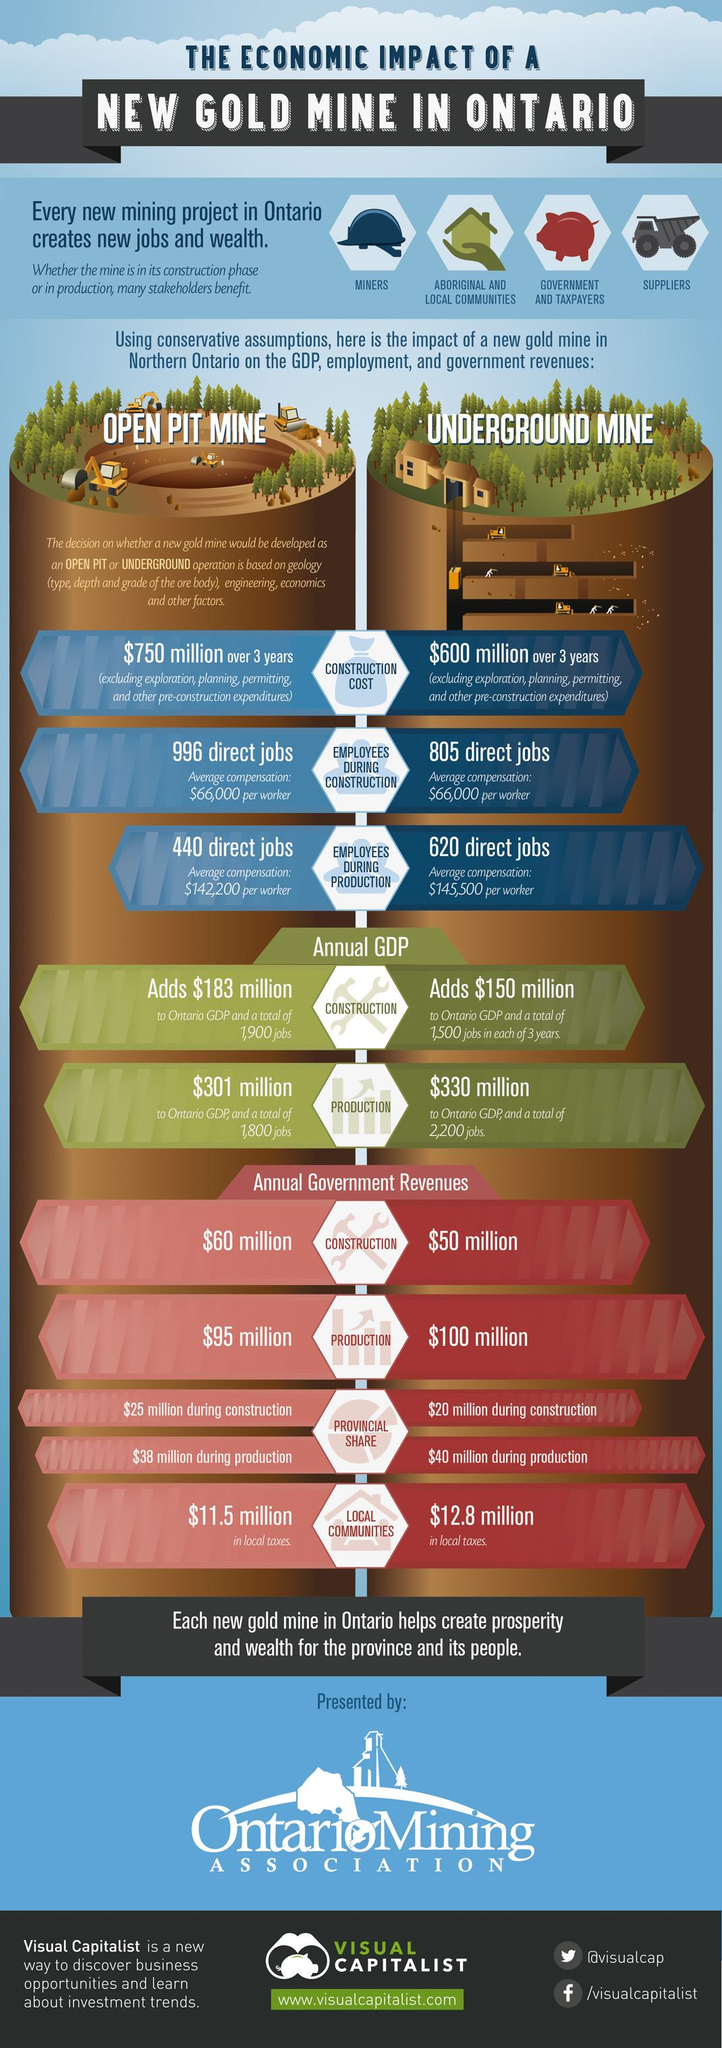Draw attention to some important aspects in this diagram. During the construction phase of an open pit gold mine in Northern Ontario, a total of 996 direct jobs will be available. The construction phase of an underground gold mine in Northern Ontario adds $150 million in value to the annual GDP of Ontario. The average compensation per worker in the construction phase of an open pit gold mine in Northern Ontario is $66,000. The annual government revenue for the production phase of an open pit gold mine in Northern Ontario is expected to be approximately $95 million. The estimated cost for constructing an underground gold mine in Northern Ontario over a period of three years is $600 million. 